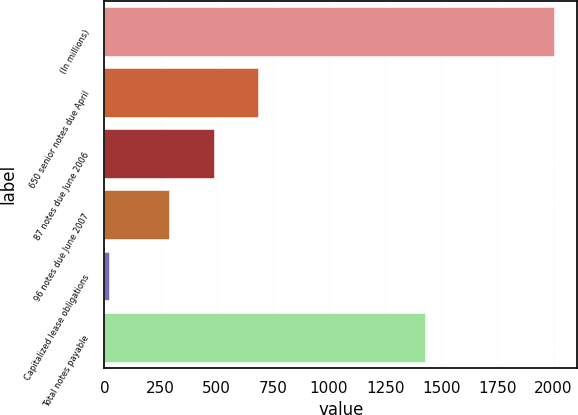Convert chart. <chart><loc_0><loc_0><loc_500><loc_500><bar_chart><fcel>(In millions)<fcel>650 senior notes due April<fcel>87 notes due June 2006<fcel>96 notes due June 2007<fcel>Capitalized lease obligations<fcel>Total notes payable<nl><fcel>2004<fcel>684.8<fcel>486.4<fcel>288<fcel>20<fcel>1429<nl></chart> 